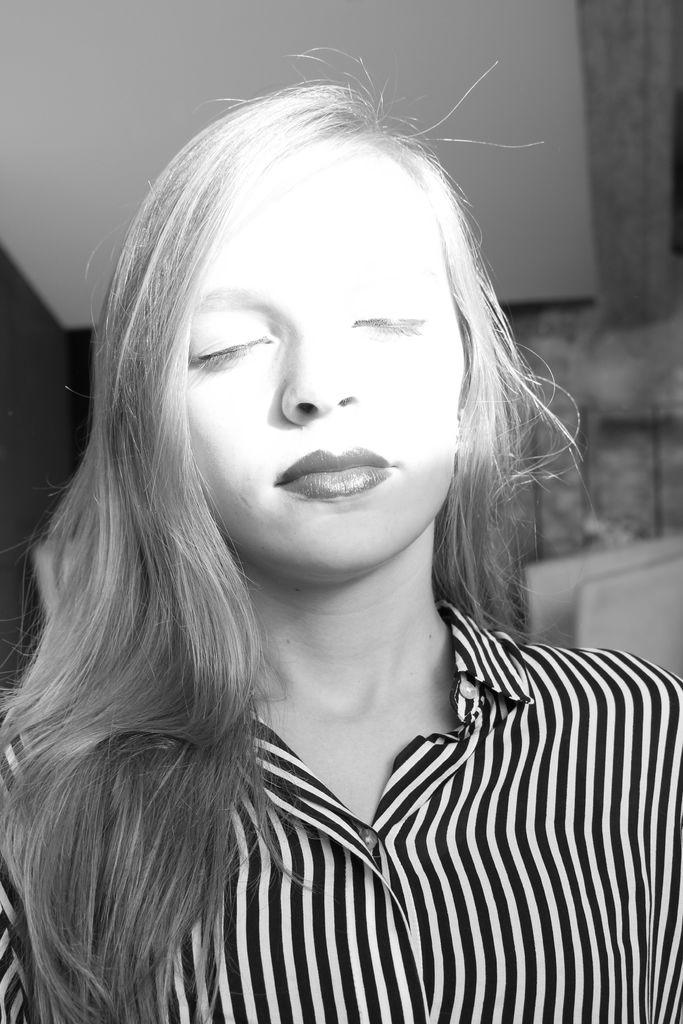Who is the main subject in the image? There is a lady in the center of the image. What can be seen in the background of the image? There is a wall in the background of the image. How much does the deer weigh in the image? There is no deer present in the image, so it is not possible to determine its weight. 